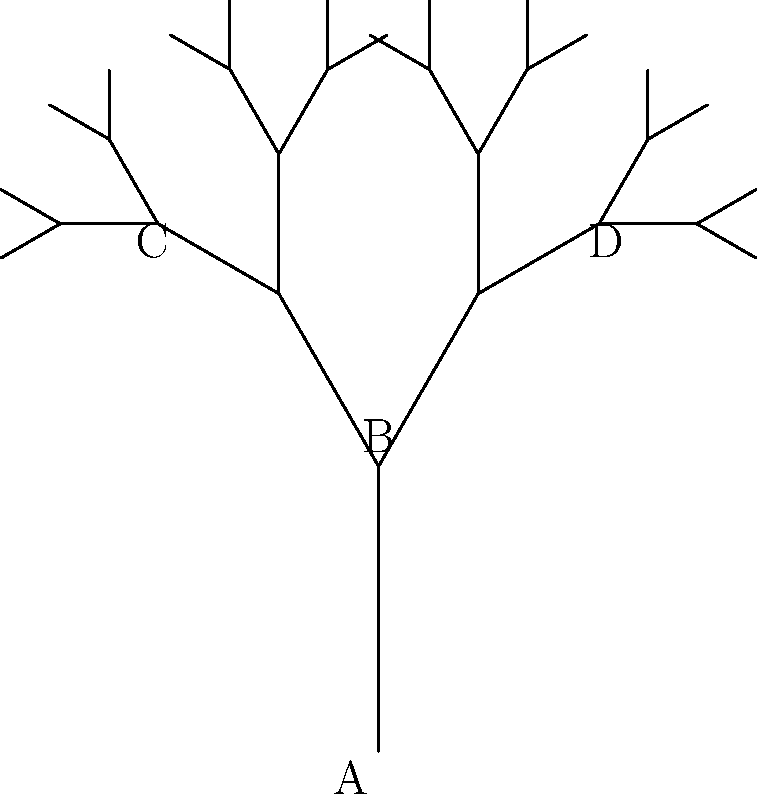In a novel with complex character relationships, the author uses a fractal-like tree structure to visualize connections. If each branch represents a character's influence on others, and the branching angle is consistently 30° on each side, what is the total number of unique paths from character A to any endpoint in the 5th generation of this tree? To solve this problem, we need to understand the fractal-like structure of the character relationship tree:

1. The tree starts with character A at the root.
2. Each character (node) influences two others, creating a binary tree structure.
3. The tree has 5 generations (depth 5).

To find the number of unique paths to the 5th generation:

1. In a binary tree, the number of nodes at each level doubles:
   - Level 1 (A): 1 node
   - Level 2 (B): 2 nodes
   - Level 3 (including C and D): 4 nodes
   - Level 4: 8 nodes
   - Level 5: 16 nodes

2. The number of endpoints in the 5th generation is equal to the number of nodes at that level: 16.

3. In a tree structure, there is always exactly one unique path from the root to any given node.

4. Therefore, the number of unique paths from A to any endpoint in the 5th generation is equal to the number of endpoints in that generation.

Thus, the total number of unique paths from character A to any endpoint in the 5th generation is 16.
Answer: 16 